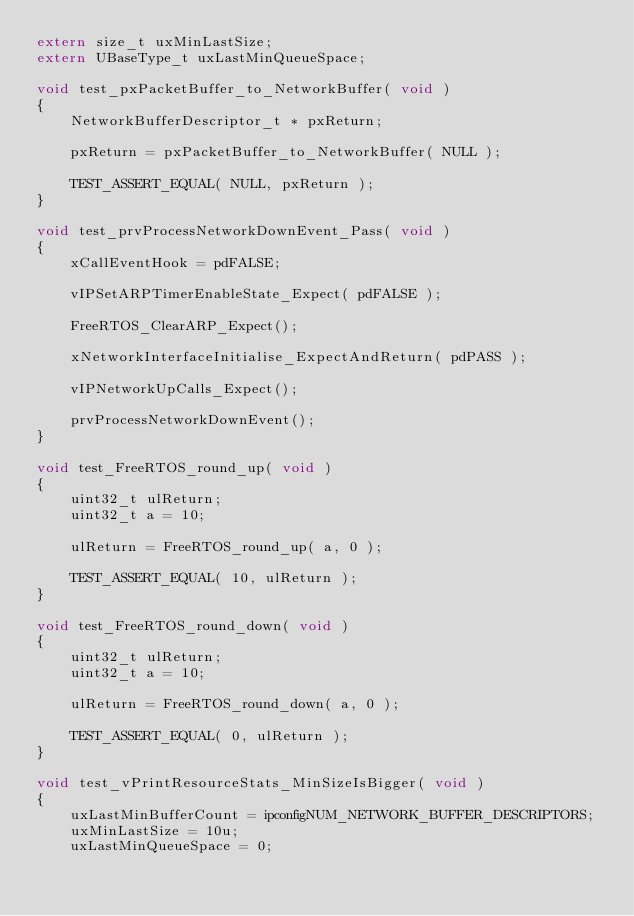<code> <loc_0><loc_0><loc_500><loc_500><_C_>extern size_t uxMinLastSize;
extern UBaseType_t uxLastMinQueueSpace;

void test_pxPacketBuffer_to_NetworkBuffer( void )
{
    NetworkBufferDescriptor_t * pxReturn;

    pxReturn = pxPacketBuffer_to_NetworkBuffer( NULL );

    TEST_ASSERT_EQUAL( NULL, pxReturn );
}

void test_prvProcessNetworkDownEvent_Pass( void )
{
    xCallEventHook = pdFALSE;

    vIPSetARPTimerEnableState_Expect( pdFALSE );

    FreeRTOS_ClearARP_Expect();

    xNetworkInterfaceInitialise_ExpectAndReturn( pdPASS );

    vIPNetworkUpCalls_Expect();

    prvProcessNetworkDownEvent();
}

void test_FreeRTOS_round_up( void )
{
    uint32_t ulReturn;
    uint32_t a = 10;

    ulReturn = FreeRTOS_round_up( a, 0 );

    TEST_ASSERT_EQUAL( 10, ulReturn );
}

void test_FreeRTOS_round_down( void )
{
    uint32_t ulReturn;
    uint32_t a = 10;

    ulReturn = FreeRTOS_round_down( a, 0 );

    TEST_ASSERT_EQUAL( 0, ulReturn );
}

void test_vPrintResourceStats_MinSizeIsBigger( void )
{
    uxLastMinBufferCount = ipconfigNUM_NETWORK_BUFFER_DESCRIPTORS;
    uxMinLastSize = 10u;
    uxLastMinQueueSpace = 0;
</code> 